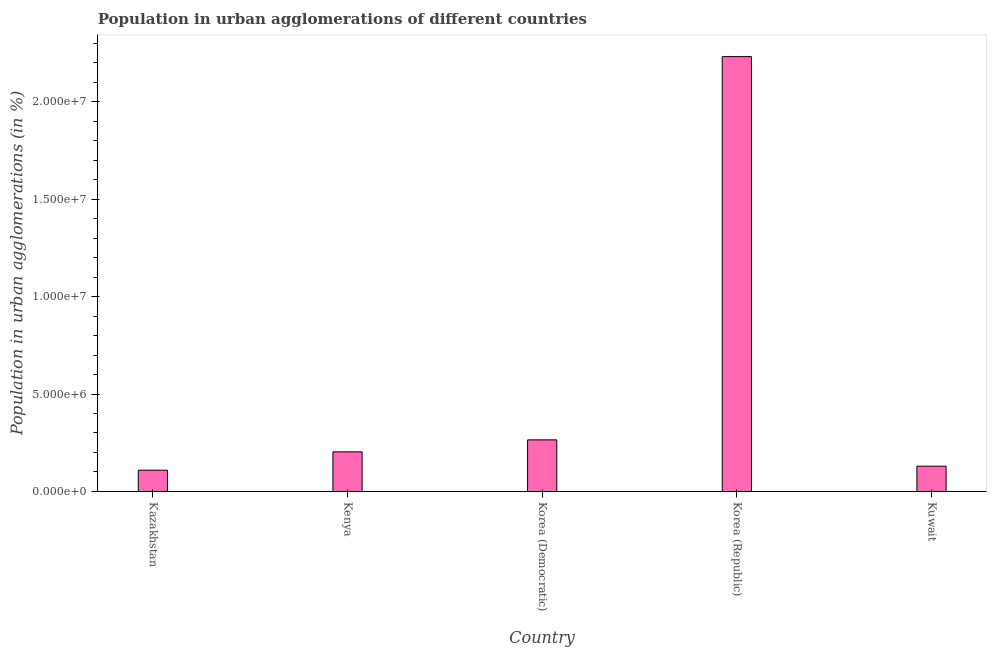Does the graph contain any zero values?
Give a very brief answer. No. Does the graph contain grids?
Ensure brevity in your answer.  No. What is the title of the graph?
Ensure brevity in your answer.  Population in urban agglomerations of different countries. What is the label or title of the Y-axis?
Your answer should be very brief. Population in urban agglomerations (in %). What is the population in urban agglomerations in Kenya?
Give a very brief answer. 2.03e+06. Across all countries, what is the maximum population in urban agglomerations?
Make the answer very short. 2.23e+07. Across all countries, what is the minimum population in urban agglomerations?
Your answer should be compact. 1.09e+06. In which country was the population in urban agglomerations maximum?
Your answer should be very brief. Korea (Republic). In which country was the population in urban agglomerations minimum?
Provide a short and direct response. Kazakhstan. What is the sum of the population in urban agglomerations?
Offer a terse response. 2.94e+07. What is the difference between the population in urban agglomerations in Kenya and Korea (Republic)?
Make the answer very short. -2.03e+07. What is the average population in urban agglomerations per country?
Provide a succinct answer. 5.88e+06. What is the median population in urban agglomerations?
Make the answer very short. 2.03e+06. What is the ratio of the population in urban agglomerations in Kazakhstan to that in Kenya?
Make the answer very short. 0.54. What is the difference between the highest and the second highest population in urban agglomerations?
Your answer should be compact. 1.97e+07. Is the sum of the population in urban agglomerations in Kazakhstan and Kenya greater than the maximum population in urban agglomerations across all countries?
Offer a very short reply. No. What is the difference between the highest and the lowest population in urban agglomerations?
Keep it short and to the point. 2.12e+07. How many bars are there?
Give a very brief answer. 5. Are the values on the major ticks of Y-axis written in scientific E-notation?
Your answer should be very brief. Yes. What is the Population in urban agglomerations (in %) in Kazakhstan?
Give a very brief answer. 1.09e+06. What is the Population in urban agglomerations (in %) of Kenya?
Give a very brief answer. 2.03e+06. What is the Population in urban agglomerations (in %) in Korea (Democratic)?
Offer a very short reply. 2.65e+06. What is the Population in urban agglomerations (in %) in Korea (Republic)?
Provide a succinct answer. 2.23e+07. What is the Population in urban agglomerations (in %) of Kuwait?
Offer a very short reply. 1.30e+06. What is the difference between the Population in urban agglomerations (in %) in Kazakhstan and Kenya?
Offer a terse response. -9.41e+05. What is the difference between the Population in urban agglomerations (in %) in Kazakhstan and Korea (Democratic)?
Keep it short and to the point. -1.56e+06. What is the difference between the Population in urban agglomerations (in %) in Kazakhstan and Korea (Republic)?
Your answer should be compact. -2.12e+07. What is the difference between the Population in urban agglomerations (in %) in Kazakhstan and Kuwait?
Offer a terse response. -2.07e+05. What is the difference between the Population in urban agglomerations (in %) in Kenya and Korea (Democratic)?
Provide a succinct answer. -6.15e+05. What is the difference between the Population in urban agglomerations (in %) in Kenya and Korea (Republic)?
Your answer should be very brief. -2.03e+07. What is the difference between the Population in urban agglomerations (in %) in Kenya and Kuwait?
Your answer should be very brief. 7.34e+05. What is the difference between the Population in urban agglomerations (in %) in Korea (Democratic) and Korea (Republic)?
Offer a very short reply. -1.97e+07. What is the difference between the Population in urban agglomerations (in %) in Korea (Democratic) and Kuwait?
Provide a short and direct response. 1.35e+06. What is the difference between the Population in urban agglomerations (in %) in Korea (Republic) and Kuwait?
Your answer should be compact. 2.10e+07. What is the ratio of the Population in urban agglomerations (in %) in Kazakhstan to that in Kenya?
Your answer should be compact. 0.54. What is the ratio of the Population in urban agglomerations (in %) in Kazakhstan to that in Korea (Democratic)?
Your answer should be compact. 0.41. What is the ratio of the Population in urban agglomerations (in %) in Kazakhstan to that in Korea (Republic)?
Provide a short and direct response. 0.05. What is the ratio of the Population in urban agglomerations (in %) in Kazakhstan to that in Kuwait?
Keep it short and to the point. 0.84. What is the ratio of the Population in urban agglomerations (in %) in Kenya to that in Korea (Democratic)?
Offer a very short reply. 0.77. What is the ratio of the Population in urban agglomerations (in %) in Kenya to that in Korea (Republic)?
Provide a short and direct response. 0.09. What is the ratio of the Population in urban agglomerations (in %) in Kenya to that in Kuwait?
Offer a very short reply. 1.56. What is the ratio of the Population in urban agglomerations (in %) in Korea (Democratic) to that in Korea (Republic)?
Provide a succinct answer. 0.12. What is the ratio of the Population in urban agglomerations (in %) in Korea (Democratic) to that in Kuwait?
Offer a very short reply. 2.04. What is the ratio of the Population in urban agglomerations (in %) in Korea (Republic) to that in Kuwait?
Your response must be concise. 17.18. 